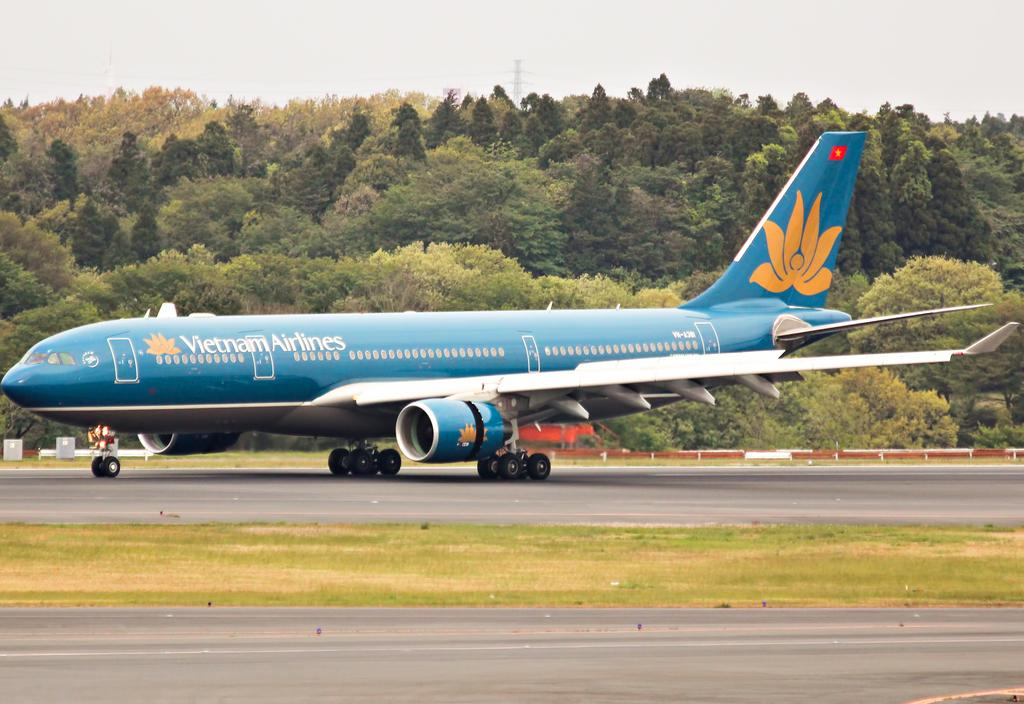<image>
Provide a brief description of the given image. A big blue plane from Vietnam Airlines on the runway. 